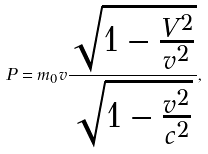Convert formula to latex. <formula><loc_0><loc_0><loc_500><loc_500>P = m _ { 0 } v \frac { \sqrt { 1 - \frac { V ^ { 2 } } { v ^ { 2 } } } } { \sqrt { 1 - \frac { v ^ { 2 } } { c ^ { 2 } } } } ,</formula> 